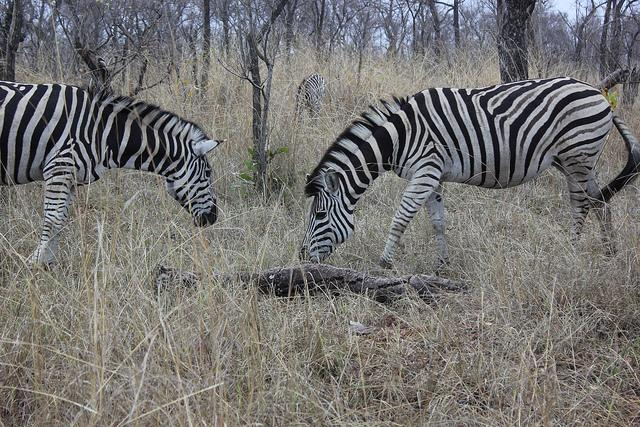What matches the color scheme of the animals?

Choices:
A) piano keys
B) lime
C) pumpkin
D) cherry piano keys 